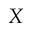Convert formula to latex. <formula><loc_0><loc_0><loc_500><loc_500>X</formula> 